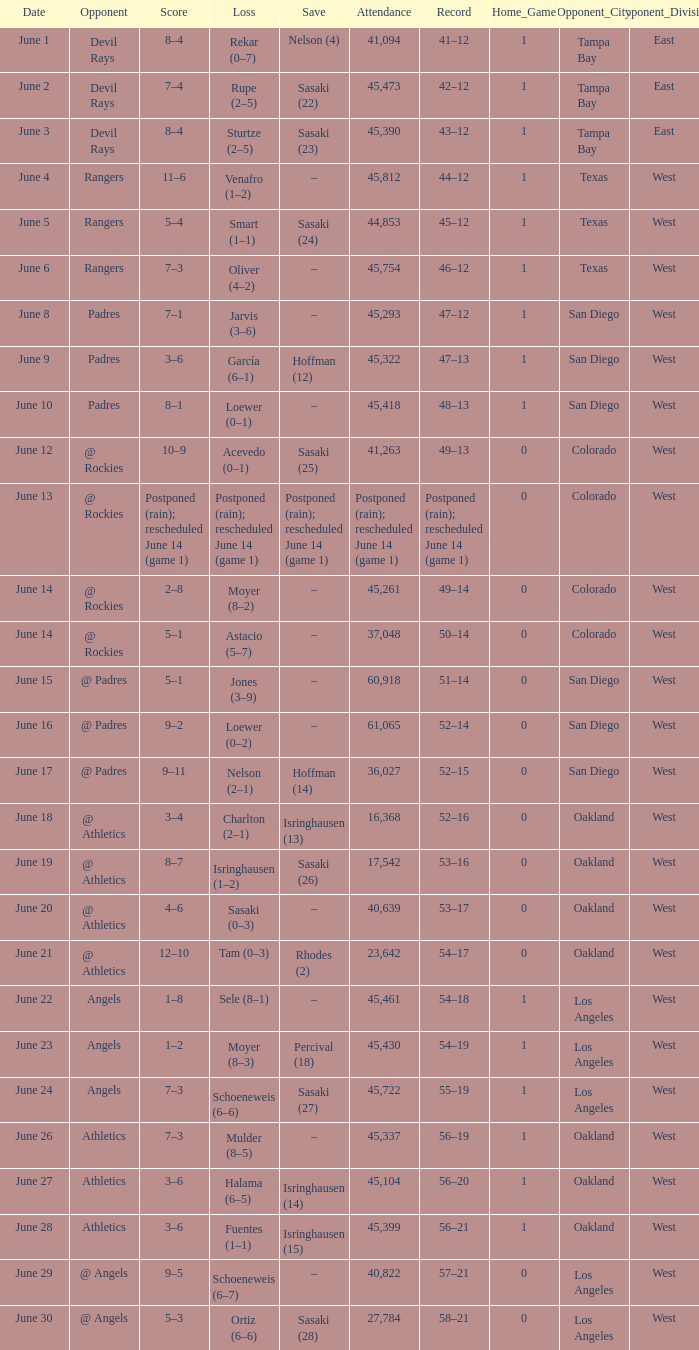What was the score of the Mariners game when they had a record of 56–21? 3–6. 